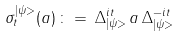Convert formula to latex. <formula><loc_0><loc_0><loc_500><loc_500>\sigma ^ { | \psi > } _ { t } ( a ) \, \colon = \, \Delta _ { | \psi > } ^ { i t } \, a \, \Delta _ { | \psi > } ^ { - i t }</formula> 